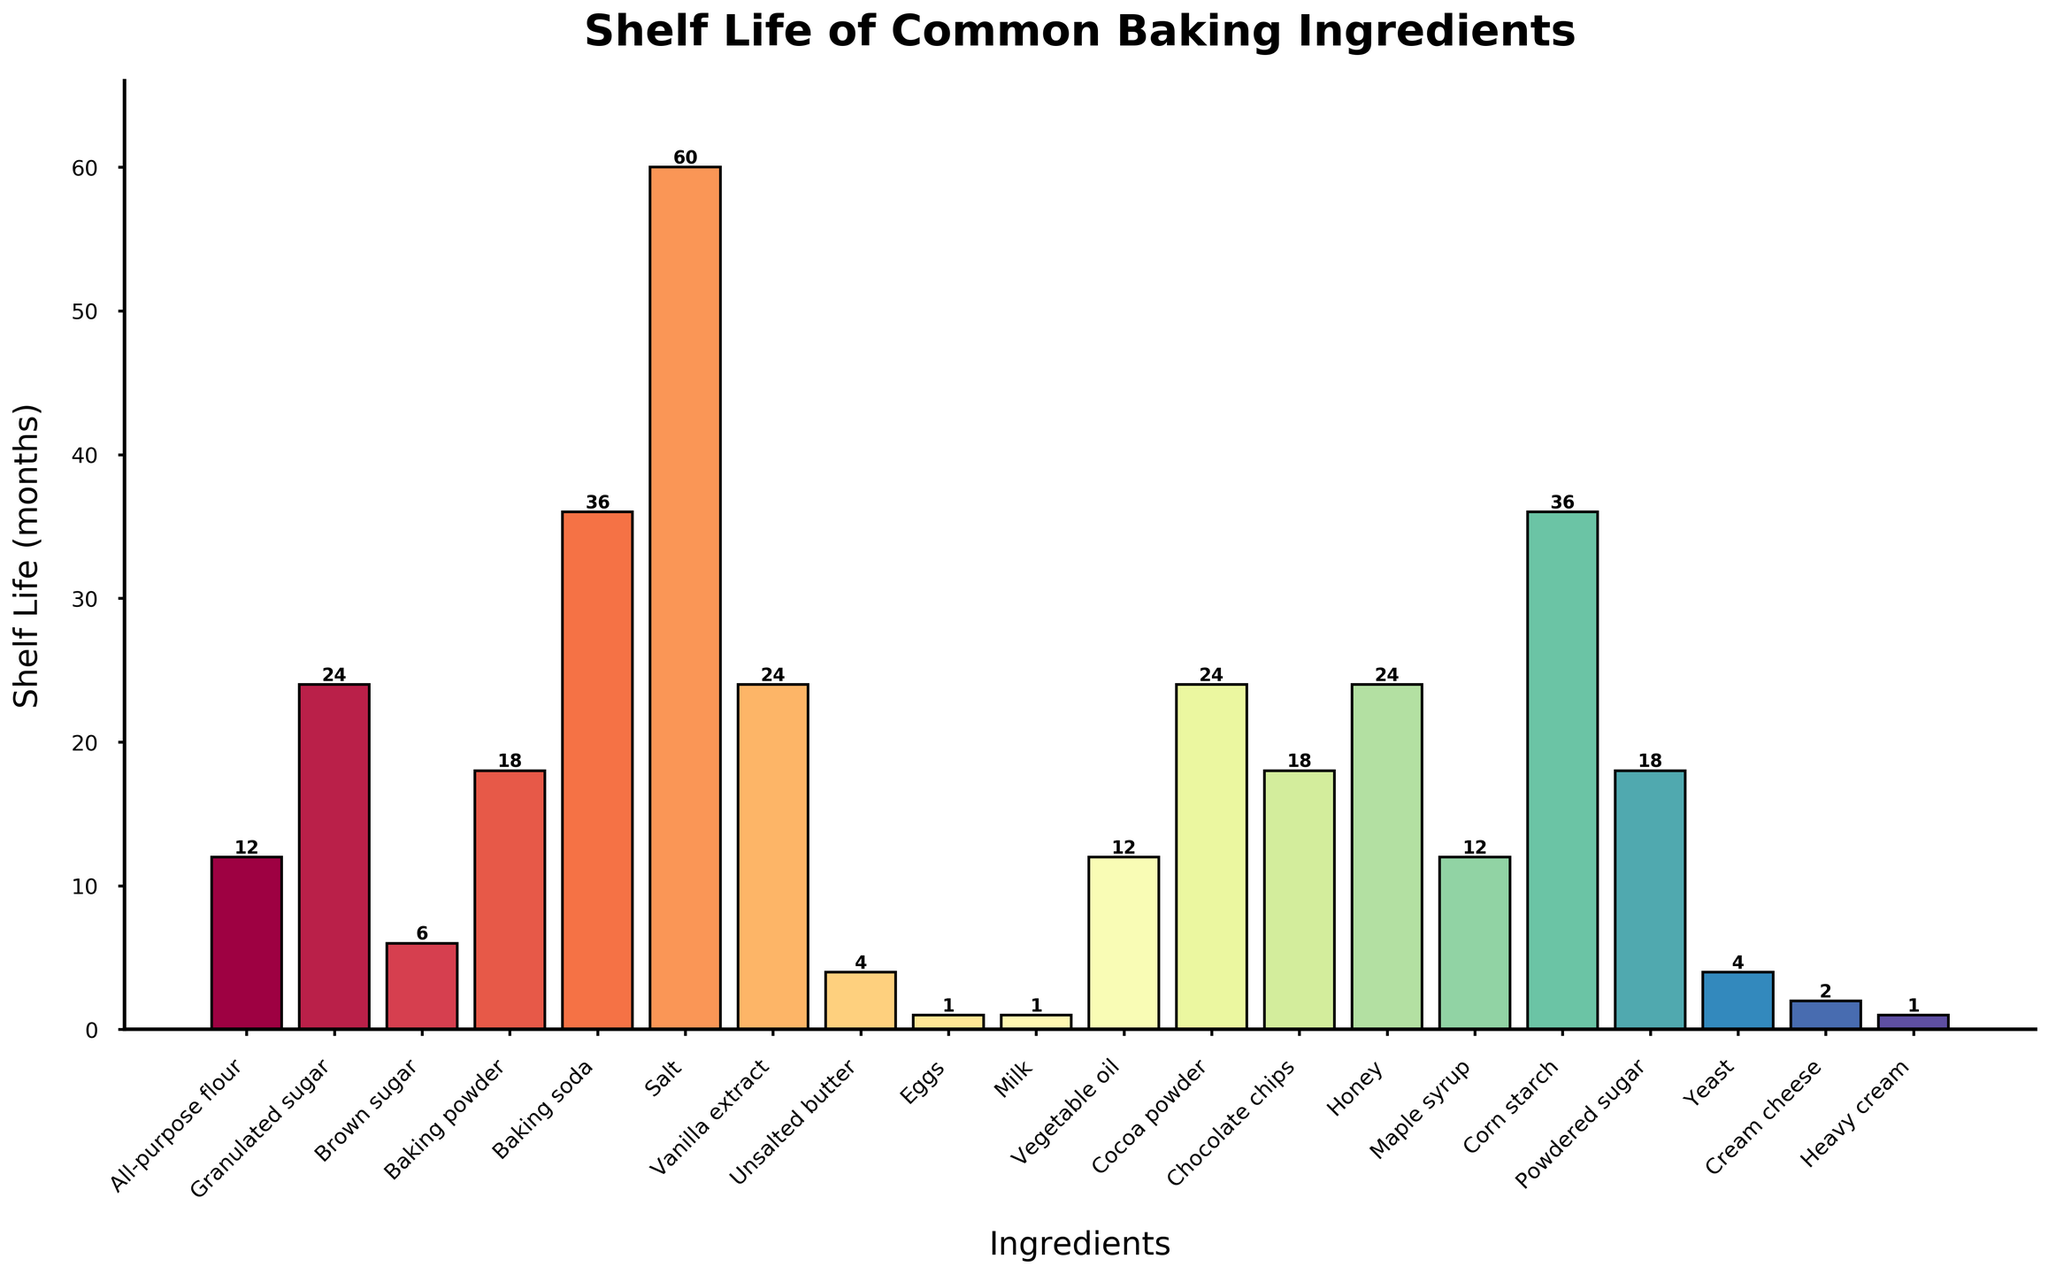Which ingredient has the shortest shelf life? The ingredient with the shortest height bar on the chart represents the shortest shelf life. This is indicated by the ingredient "Eggs" with a shelf life of 1 month.
Answer: Eggs Which ingredient has the longest shelf life? The ingredient with the tallest bar on the chart represents the longest shelf life. This is indicated by the ingredient "Salt" with a shelf life of 60 months.
Answer: Salt How much longer is the shelf life of Salt compared to Unsalted butter? The shelf life of Salt is 60 months, and the shelf life of Unsalted butter is 4 months. The difference can be calculated as 60 - 4 = 56 months.
Answer: 56 months Which two ingredients have a shelf life of 36 months? By examining the height of bars that reach the level corresponding to 36 months, the ingredients are "Baking soda" and "Corn starch."
Answer: Baking soda and Corn starch What is the combined shelf life of Honey and Vanilla extract? The shelf life of Honey is 24 months, and the shelf life of Vanilla extract is also 24 months. The combined shelf life is calculated as 24 + 24 = 48 months.
Answer: 48 months Are there more ingredients with a shelf life of 24 months or 18 months? By counting the bars that reach the levels corresponding to 24 months (Granulated sugar, Vanilla extract, Cocoa powder, and Honey) and 18 months (Baking powder, Chocolate chips, and Powdered sugar), there are more ingredients with a 24-month shelf life.
Answer: 24 months Is the shelf life of Yeast less than the combined shelf life of Eggs, Unsalted butter, and Heavy cream? Shelf life of Yeast is 4 months. The combined shelf life of Eggs (1 month), Unsalted butter (4 months), and Heavy cream (1 month) is 1 + 4 + 1 = 6 months. Since 4 < 6, the shelf life of Yeast is less.
Answer: Yes Which ingredient has a shelf life equal to the sum of the shelf lives of Eggs and Cream Cheese? The shelf life of Eggs is 1 month, and the shelf life of Cream Cheese is 2 months. Their sum is 1 + 2 = 3 months. No ingredients have a shelf life of 3 months on the chart.
Answer: None What is the average shelf life of baking powders and sugars (including Granulated sugar, Brown sugar, and Powdered sugar)? The shelf lives are: Baking powder (18 months), Granulated sugar (24 months), Brown sugar (6 months), and Powdered sugar (18 months). The average is (18 + 24 + 6 + 18) / 4 = 66 / 4 = 16.5 months.
Answer: 16.5 months 